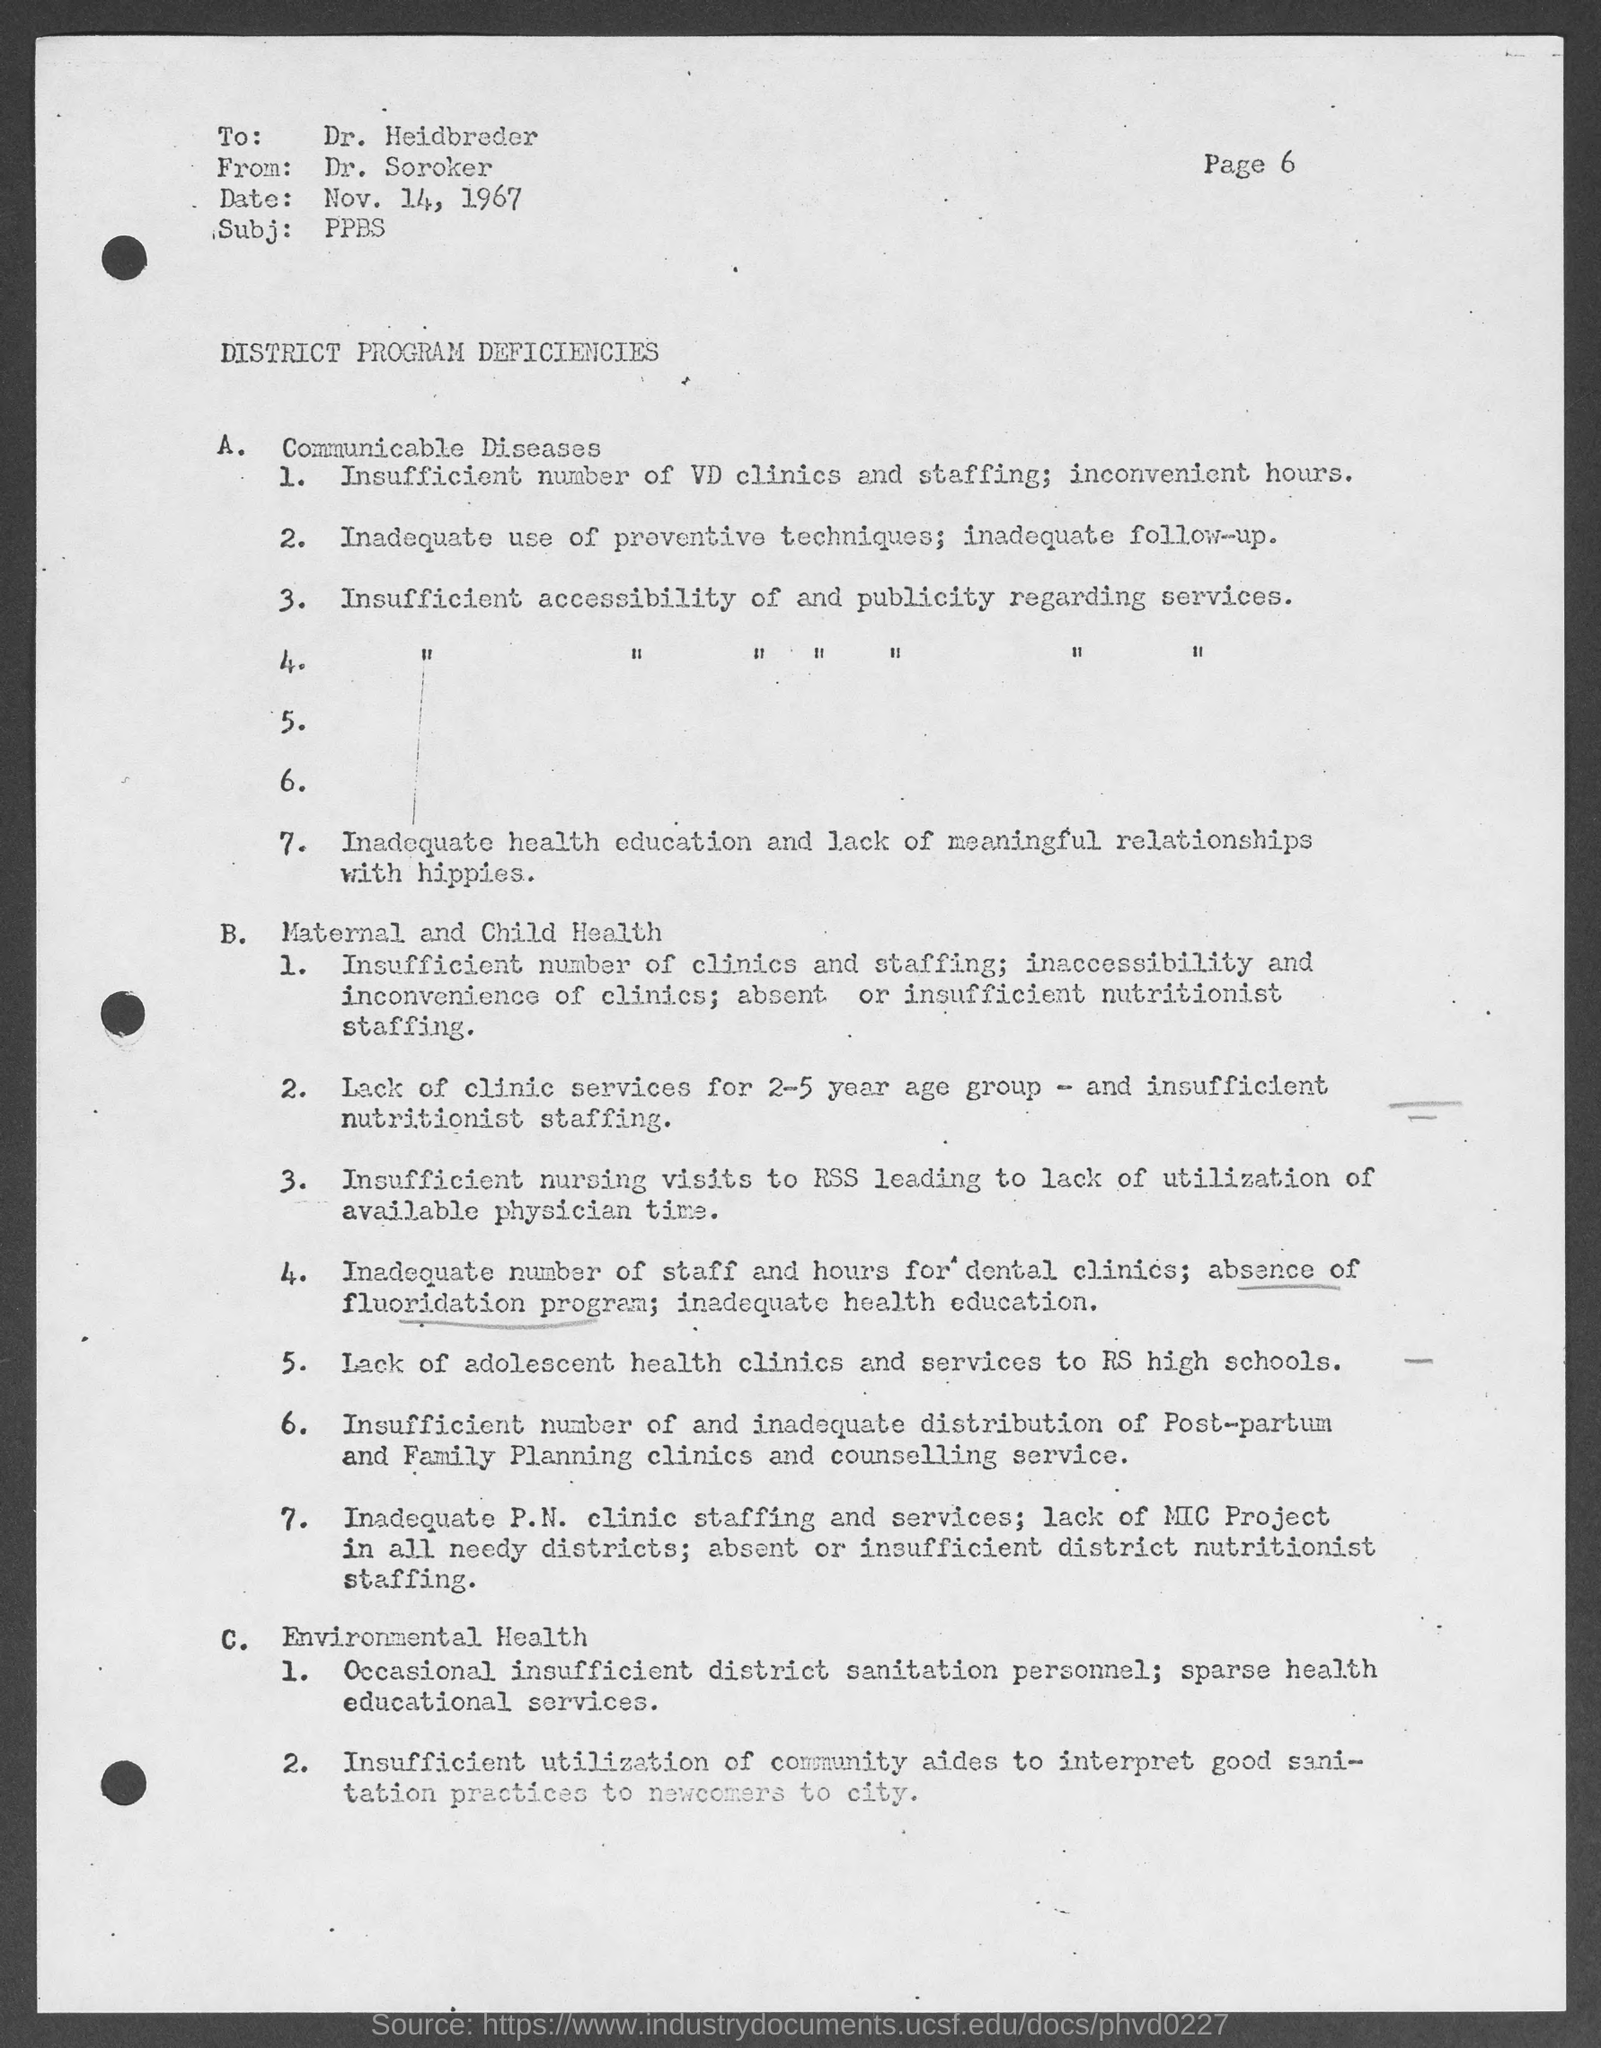Highlight a few significant elements in this photo. The recipient of this document is Dr. Heidbreder. The document contains the text "What is the date mentioned in this document? Nov. 14, 1967.." which provides information about a date. The sender of this document is Dr. Soroker. The subject mentioned in the document is "PPBS..". 